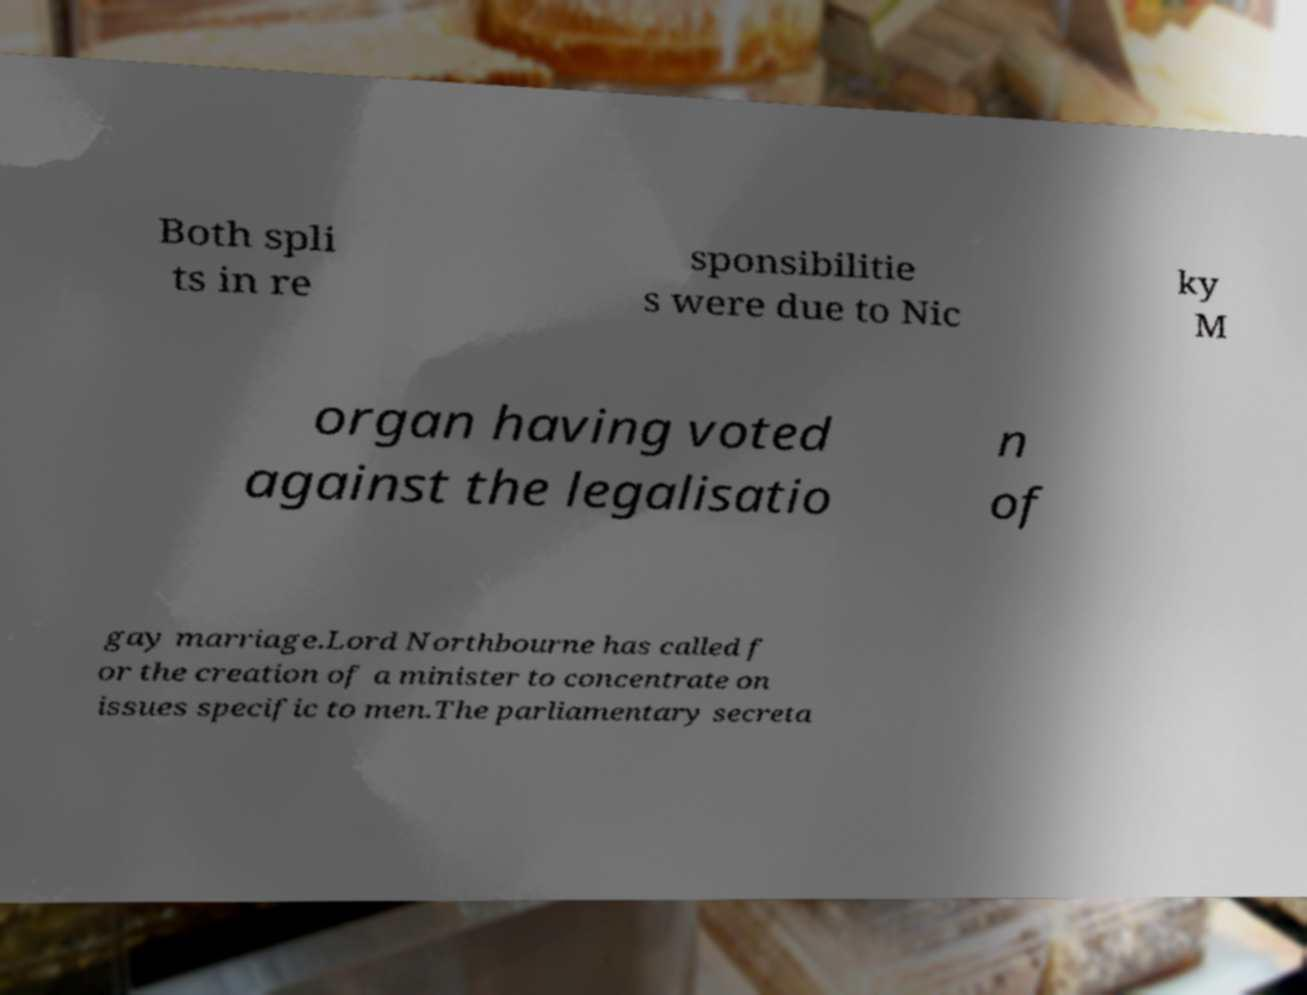Please read and relay the text visible in this image. What does it say? Both spli ts in re sponsibilitie s were due to Nic ky M organ having voted against the legalisatio n of gay marriage.Lord Northbourne has called f or the creation of a minister to concentrate on issues specific to men.The parliamentary secreta 